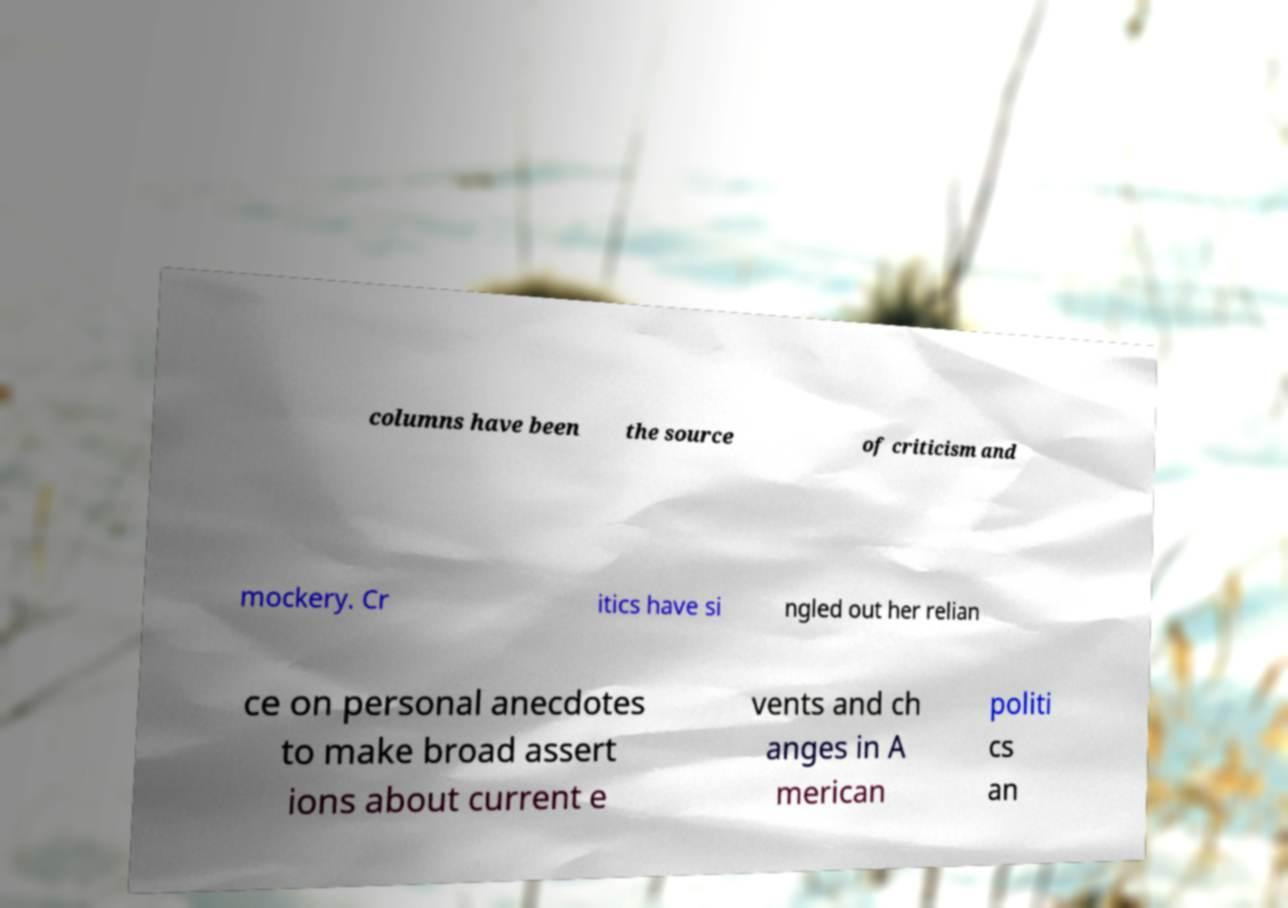Please read and relay the text visible in this image. What does it say? columns have been the source of criticism and mockery. Cr itics have si ngled out her relian ce on personal anecdotes to make broad assert ions about current e vents and ch anges in A merican politi cs an 